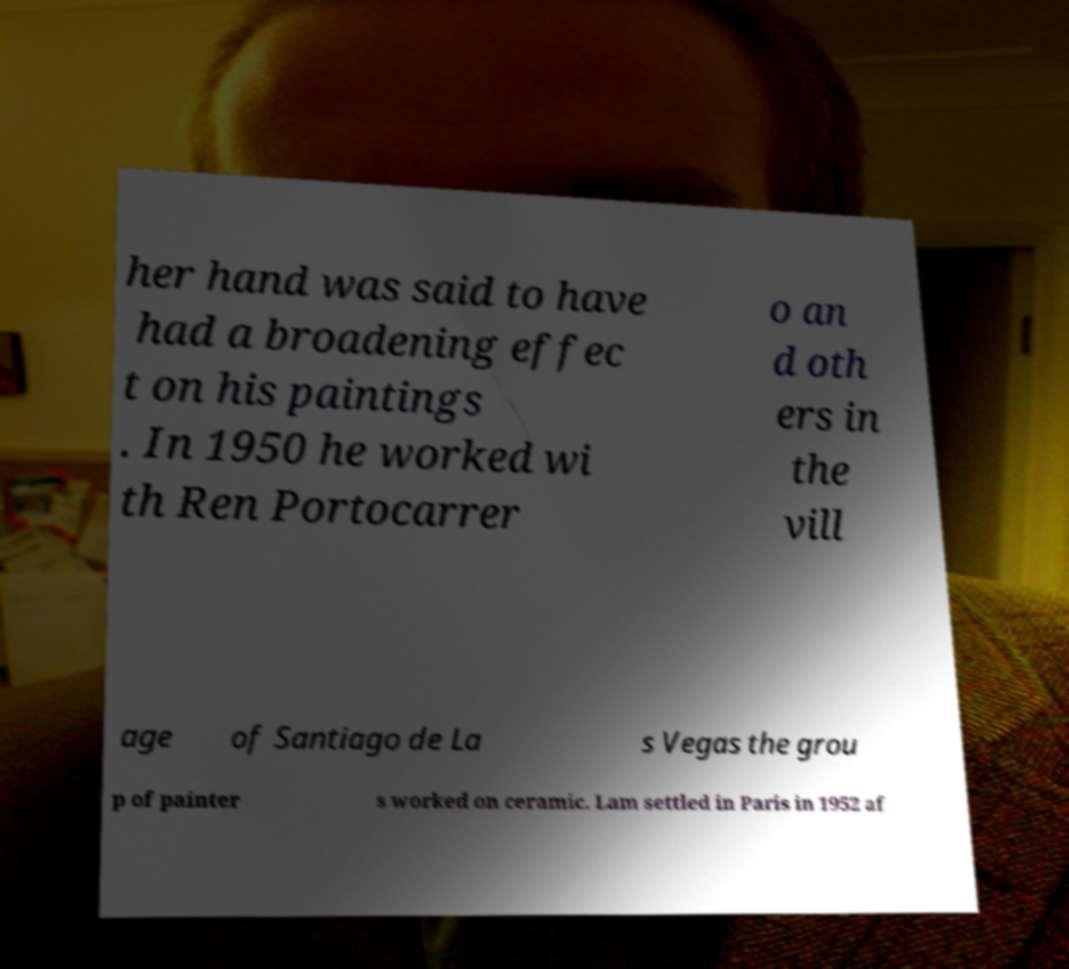Please read and relay the text visible in this image. What does it say? her hand was said to have had a broadening effec t on his paintings . In 1950 he worked wi th Ren Portocarrer o an d oth ers in the vill age of Santiago de La s Vegas the grou p of painter s worked on ceramic. Lam settled in Paris in 1952 af 